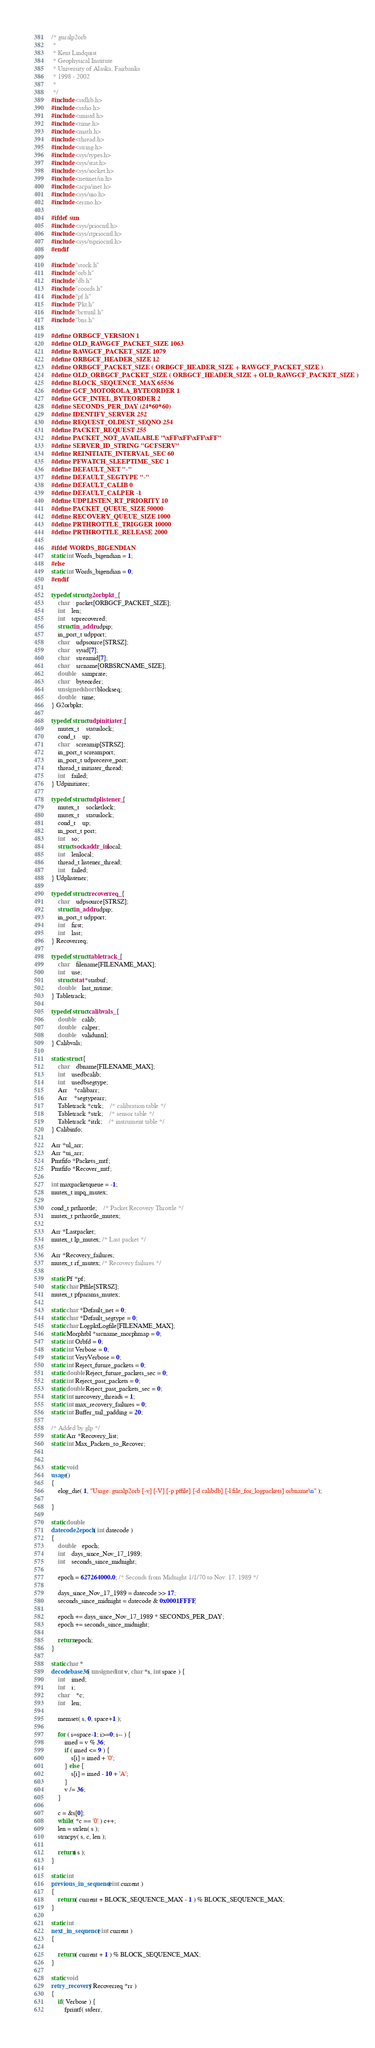<code> <loc_0><loc_0><loc_500><loc_500><_C_>/* guralp2orb
 *
 * Kent Lindquist
 * Geophysical Institute
 * University of Alaska, Fairbanks
 * 1998 - 2002
 *
 */
#include <stdlib.h>
#include <stdio.h>
#include <unistd.h>
#include <time.h>
#include <math.h>
#include <thread.h>
#include <string.h>
#include <sys/types.h>
#include <sys/stat.h>
#include <sys/socket.h>
#include <netinet/in.h>
#include <arpa/inet.h>
#include <sys/uio.h>
#include <errno.h>

#ifdef sun
#include <sys/priocntl.h>
#include <sys/rtpriocntl.h>
#include <sys/tspriocntl.h>
#endif

#include "stock.h"
#include "orb.h"
#include "db.h"
#include "coords.h"
#include "pf.h"
#include "Pkt.h"
#include "brttutil.h"
#include "bns.h"

#define ORBGCF_VERSION 1
#define OLD_RAWGCF_PACKET_SIZE 1063
#define RAWGCF_PACKET_SIZE 1079
#define ORBGCF_HEADER_SIZE 12
#define ORBGCF_PACKET_SIZE ( ORBGCF_HEADER_SIZE + RAWGCF_PACKET_SIZE )
#define OLD_ORBGCF_PACKET_SIZE ( ORBGCF_HEADER_SIZE + OLD_RAWGCF_PACKET_SIZE )
#define BLOCK_SEQUENCE_MAX 65536
#define GCF_MOTOROLA_BYTEORDER 1
#define GCF_INTEL_BYTEORDER 2
#define SECONDS_PER_DAY (24*60*60)
#define IDENTIFY_SERVER 252
#define REQUEST_OLDEST_SEQNO 254
#define PACKET_REQUEST 255
#define PACKET_NOT_AVAILABLE "\xFF\xFF\xFF\xFF"
#define SERVER_ID_STRING "GCFSERV"
#define REINITIATE_INTERVAL_SEC 60
#define PFWATCH_SLEEPTIME_SEC 1
#define DEFAULT_NET "-"
#define DEFAULT_SEGTYPE "-"
#define DEFAULT_CALIB 0
#define DEFAULT_CALPER -1
#define UDPLISTEN_RT_PRIORITY 10
#define PACKET_QUEUE_SIZE 50000
#define RECOVERY_QUEUE_SIZE 1000
#define PRTHROTTLE_TRIGGER 10000
#define PRTHROTTLE_RELEASE 2000

#ifdef WORDS_BIGENDIAN
static int Words_bigendian = 1;
#else
static int Words_bigendian = 0;
#endif

typedef struct g2orbpkt_ {
	char	packet[ORBGCF_PACKET_SIZE];
	int	len;
	int	tcprecovered;
	struct in_addr udpip;
	in_port_t udpport;
	char	udpsource[STRSZ];
	char	sysid[7];
	char	streamid[7];
	char	srcname[ORBSRCNAME_SIZE];
	double	samprate;
	char	byteorder;
	unsigned short blockseq;
	double	time;
} G2orbpkt;

typedef struct udpinitiater_ {
	mutex_t	statuslock;
	cond_t	up;
	char	screamip[STRSZ];
	in_port_t screamport;
	in_port_t udpreceive_port;
	thread_t initiater_thread;
	int 	failed;
} Udpinitiater;

typedef struct udplistener_ {
	mutex_t	socketlock;
	mutex_t	statuslock;
	cond_t	up;
	in_port_t port;
	int	so;
	struct sockaddr_in local;
	int	lenlocal;
	thread_t listener_thread;
	int	failed;
} Udplistener;

typedef struct recoverreq_ {
	char	udpsource[STRSZ];
	struct in_addr udpip;
	in_port_t udpport;
	int	first;
	int	last;
} Recoverreq;

typedef struct tabletrack_ {
	char	filename[FILENAME_MAX];
	int	use;
	struct stat *statbuf;
	double	last_mtime;
} Tabletrack;

typedef struct calibvals_ {
	double	calib;
	double 	calper;
	double 	validuntil;
} Calibvals;

static struct {
	char 	dbname[FILENAME_MAX];
	int	usedbcalib;
	int	usedbsegtype;
	Arr	*calibarr;	
	Arr	*segtypearr;
	Tabletrack *ctrk;	/* calibration table */
	Tabletrack *strk;	/* sensor table */
	Tabletrack *itrk;	/* instrument table */
} Calibinfo;

Arr *ul_arr; 
Arr *ui_arr; 
Pmtfifo *Packets_mtf;
Pmtfifo *Recover_mtf;

int maxpacketqueue = -1;
mutex_t mpq_mutex;

cond_t prthrottle;	/* Packet Recovery Throttle */
mutex_t prthrottle_mutex;

Arr *Lastpacket;
mutex_t lp_mutex; /* Last packet */

Arr *Recovery_failures;
mutex_t rf_mutex; /* Recovery failures */

static Pf *pf;
static char Pffile[STRSZ];
mutex_t pfparams_mutex;

static char *Default_net = 0;
static char *Default_segtype = 0;
static char LogpktLogfile[FILENAME_MAX];
static Morphtbl *srcname_morphmap = 0;
static int Orbfd = 0; 
static int Verbose = 0;
static int VeryVerbose = 0;
static int Reject_future_packets = 0;
static double Reject_future_packets_sec = 0;
static int Reject_past_packets = 0;
static double Reject_past_packets_sec = 0;
static int nrecovery_threads = 1;
static int max_recovery_failures = 0;
static int Buffer_tail_padding = 20;

/* Added by glp */
static Arr *Recovery_list;
static int Max_Packets_to_Recover;


static void
usage()
{
	elog_die( 1, "Usage: guralp2orb [-v] [-V] [-p pffile] [-d calibdb] [-l file_for_logpackets] orbname\n" );
	
}

static double 
datecode2epoch( int datecode )
{
	double 	epoch;
	int	days_since_Nov_17_1989;	
	int	seconds_since_midnight;

	epoch = 627264000.0; /* Seconds from Midnight 1/1/70 to Nov. 17, 1989 */

	days_since_Nov_17_1989 = datecode >> 17;
	seconds_since_midnight = datecode & 0x0001FFFF;

	epoch += days_since_Nov_17_1989 * SECONDS_PER_DAY;
	epoch += seconds_since_midnight;

	return epoch;
}

static char *
decodebase36( unsigned int v, char *s, int space ) {
	int 	imed;
	int	i;
	char	*c;
	int	len;

	memset( s, 0, space+1 );

	for ( i=space-1; i>=0; i-- ) {
		imed = v % 36;
		if ( imed <= 9 ) {
			s[i] = imed + '0';
		} else {
			s[i] = imed - 10 + 'A';
		}
		v /= 36;
	}
	
	c = &s[0];
	while( *c == '0' ) c++;
	len = strlen( s );
	strncpy( s, c, len );

	return( s );
}

static int 
previous_in_sequence( int current )
{
	return ( current + BLOCK_SEQUENCE_MAX - 1 ) % BLOCK_SEQUENCE_MAX;
}

static int 
next_in_sequence( int current )
{

	return ( current + 1 ) % BLOCK_SEQUENCE_MAX;
}

static void
retry_recovery( Recoverreq *rr )
{
	if( Verbose ) {
		fprintf( stderr, </code> 